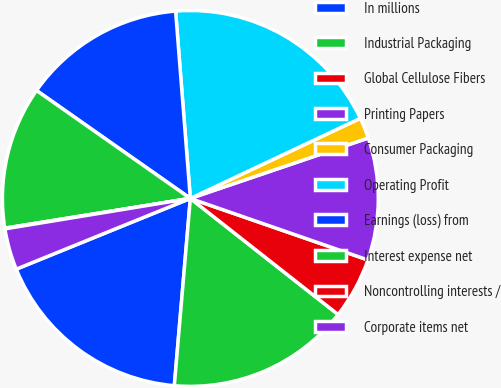<chart> <loc_0><loc_0><loc_500><loc_500><pie_chart><fcel>In millions<fcel>Industrial Packaging<fcel>Global Cellulose Fibers<fcel>Printing Papers<fcel>Consumer Packaging<fcel>Operating Profit<fcel>Earnings (loss) from<fcel>Interest expense net<fcel>Noncontrolling interests /<fcel>Corporate items net<nl><fcel>17.5%<fcel>15.76%<fcel>5.29%<fcel>10.52%<fcel>1.8%<fcel>19.24%<fcel>14.01%<fcel>12.27%<fcel>0.06%<fcel>3.55%<nl></chart> 